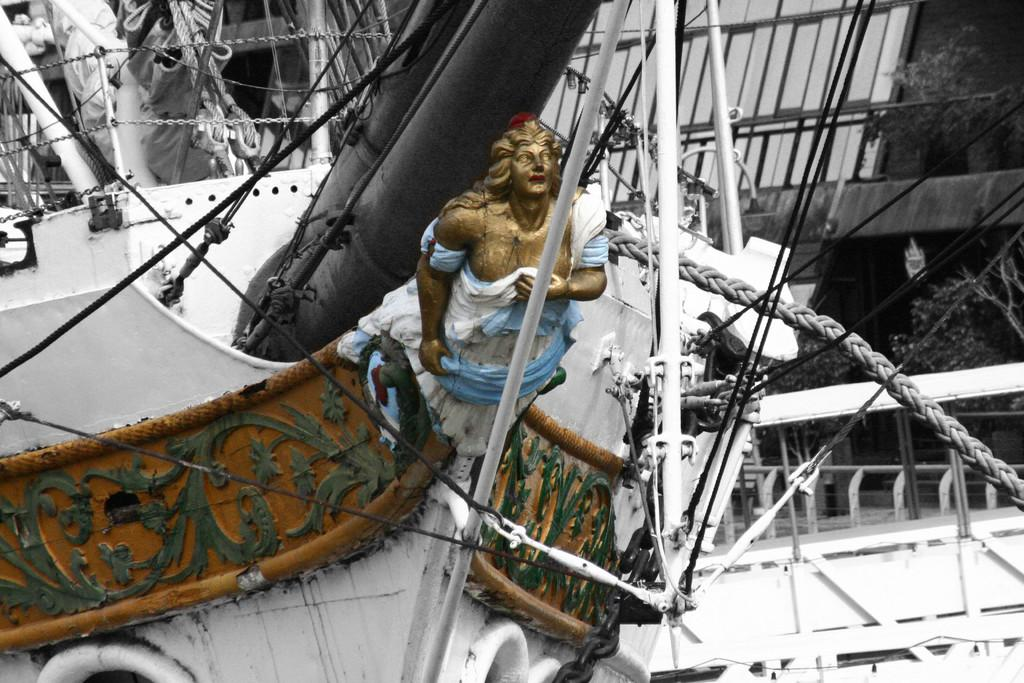What is the main subject in the center of the image? There is a ship in the center of the image. What can be found inside the ship? There is a sculpture in the ship. What can be seen in the background of the image? There is a fence and plants visible in the background of the image. What type of cloth is being used by the monkey to whistle in the image? There is no monkey or cloth present in the image, and no whistling is taking place. 